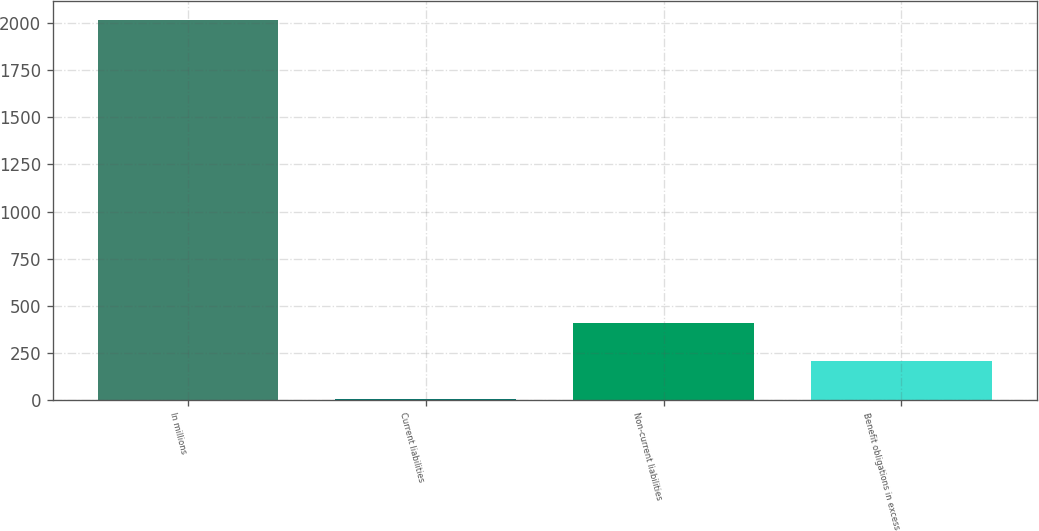Convert chart. <chart><loc_0><loc_0><loc_500><loc_500><bar_chart><fcel>In millions<fcel>Current liabilities<fcel>Non-current liabilities<fcel>Benefit obligations in excess<nl><fcel>2015<fcel>4<fcel>406.2<fcel>205.1<nl></chart> 